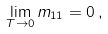Convert formula to latex. <formula><loc_0><loc_0><loc_500><loc_500>\lim _ { T \rightarrow 0 } m _ { 1 1 } = 0 \, ,</formula> 